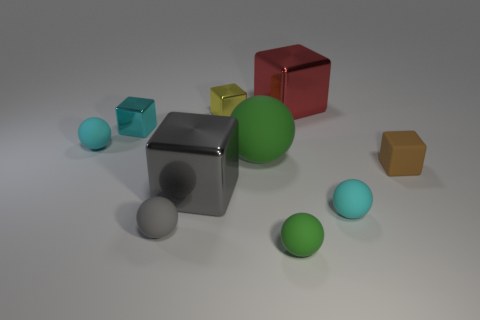Is the number of tiny cyan metal objects that are right of the red object greater than the number of yellow metal balls?
Provide a short and direct response. No. Is there a large yellow metallic ball?
Make the answer very short. No. What number of yellow objects have the same size as the brown block?
Offer a very short reply. 1. Is the number of gray rubber balls that are to the right of the brown cube greater than the number of yellow objects right of the large red metallic block?
Provide a short and direct response. No. There is a green ball that is the same size as the cyan metal block; what is it made of?
Offer a terse response. Rubber. There is a gray matte thing; what shape is it?
Offer a terse response. Sphere. How many green objects are large cubes or large spheres?
Ensure brevity in your answer.  1. What size is the cyan cube that is made of the same material as the yellow thing?
Provide a short and direct response. Small. Do the large cube behind the brown object and the gray object behind the small gray object have the same material?
Offer a terse response. Yes. What number of cylinders are cyan metallic things or big matte things?
Give a very brief answer. 0. 